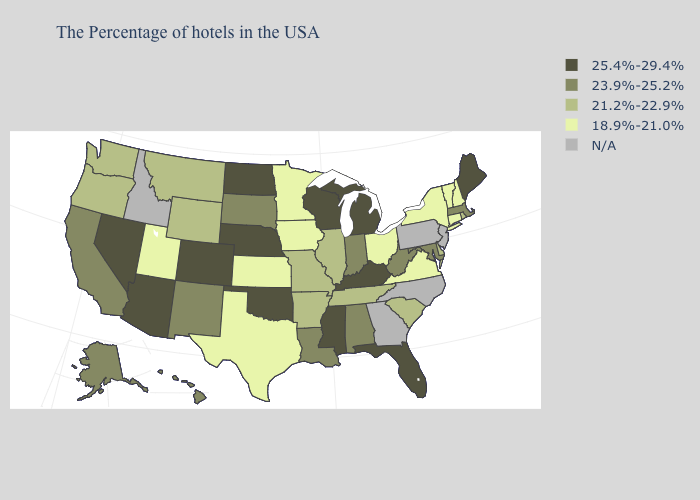What is the lowest value in states that border New Hampshire?
Keep it brief. 18.9%-21.0%. Does the first symbol in the legend represent the smallest category?
Short answer required. No. Name the states that have a value in the range 23.9%-25.2%?
Answer briefly. Massachusetts, Maryland, West Virginia, Indiana, Alabama, Louisiana, South Dakota, New Mexico, California, Alaska, Hawaii. Name the states that have a value in the range 18.9%-21.0%?
Give a very brief answer. New Hampshire, Vermont, Connecticut, New York, Virginia, Ohio, Minnesota, Iowa, Kansas, Texas, Utah. Name the states that have a value in the range 25.4%-29.4%?
Answer briefly. Maine, Florida, Michigan, Kentucky, Wisconsin, Mississippi, Nebraska, Oklahoma, North Dakota, Colorado, Arizona, Nevada. What is the lowest value in the Northeast?
Quick response, please. 18.9%-21.0%. Does Louisiana have the highest value in the South?
Answer briefly. No. What is the value of Delaware?
Quick response, please. 21.2%-22.9%. Name the states that have a value in the range 21.2%-22.9%?
Quick response, please. Rhode Island, Delaware, South Carolina, Tennessee, Illinois, Missouri, Arkansas, Wyoming, Montana, Washington, Oregon. What is the value of North Dakota?
Concise answer only. 25.4%-29.4%. What is the value of Colorado?
Keep it brief. 25.4%-29.4%. What is the highest value in the USA?
Keep it brief. 25.4%-29.4%. Does Minnesota have the highest value in the USA?
Concise answer only. No. Does the first symbol in the legend represent the smallest category?
Concise answer only. No. Among the states that border North Carolina , does Virginia have the highest value?
Quick response, please. No. 